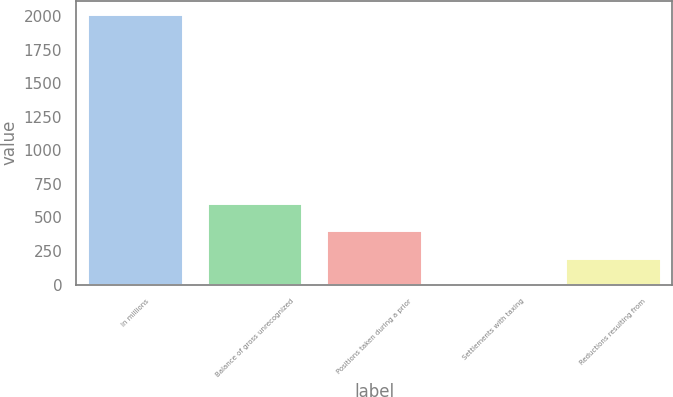Convert chart. <chart><loc_0><loc_0><loc_500><loc_500><bar_chart><fcel>In millions<fcel>Balance of gross unrecognized<fcel>Positions taken during a prior<fcel>Settlements with taxing<fcel>Reductions resulting from<nl><fcel>2012<fcel>604.3<fcel>403.2<fcel>1<fcel>202.1<nl></chart> 